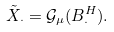<formula> <loc_0><loc_0><loc_500><loc_500>\tilde { X } _ { \cdot } = \mathcal { G } _ { \mu } ( B _ { \cdot } ^ { H } ) .</formula> 